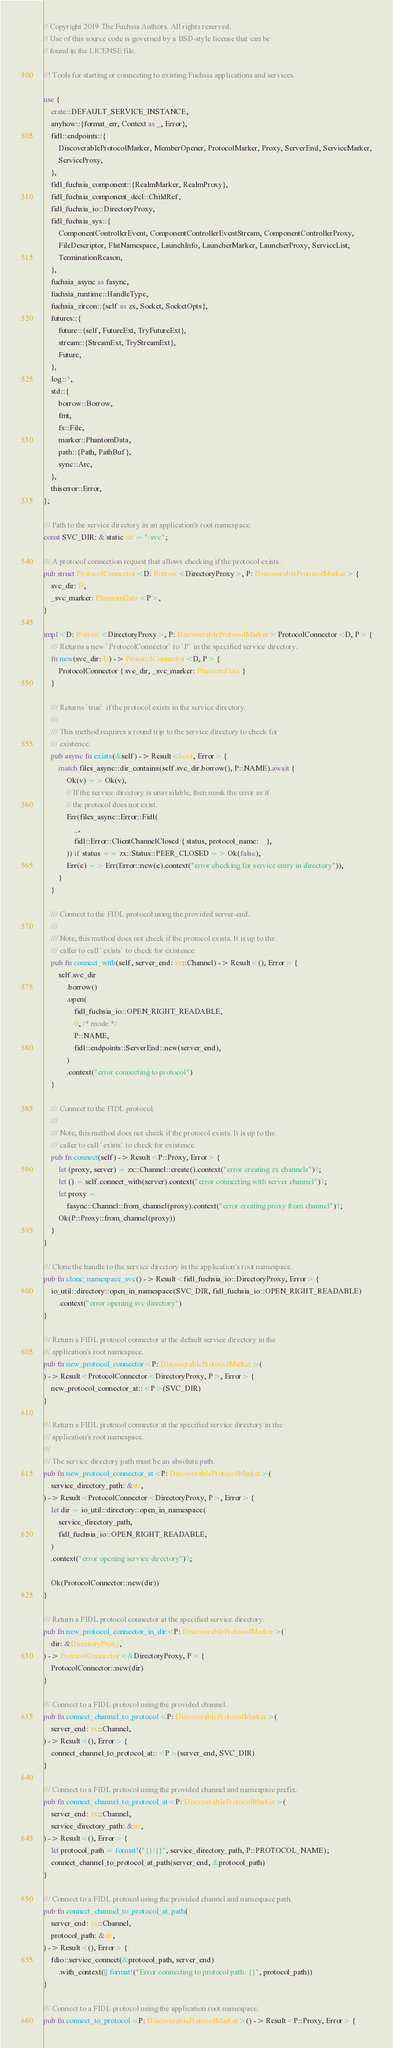<code> <loc_0><loc_0><loc_500><loc_500><_Rust_>// Copyright 2019 The Fuchsia Authors. All rights reserved.
// Use of this source code is governed by a BSD-style license that can be
// found in the LICENSE file.

//! Tools for starting or connecting to existing Fuchsia applications and services.

use {
    crate::DEFAULT_SERVICE_INSTANCE,
    anyhow::{format_err, Context as _, Error},
    fidl::endpoints::{
        DiscoverableProtocolMarker, MemberOpener, ProtocolMarker, Proxy, ServerEnd, ServiceMarker,
        ServiceProxy,
    },
    fidl_fuchsia_component::{RealmMarker, RealmProxy},
    fidl_fuchsia_component_decl::ChildRef,
    fidl_fuchsia_io::DirectoryProxy,
    fidl_fuchsia_sys::{
        ComponentControllerEvent, ComponentControllerEventStream, ComponentControllerProxy,
        FileDescriptor, FlatNamespace, LaunchInfo, LauncherMarker, LauncherProxy, ServiceList,
        TerminationReason,
    },
    fuchsia_async as fasync,
    fuchsia_runtime::HandleType,
    fuchsia_zircon::{self as zx, Socket, SocketOpts},
    futures::{
        future::{self, FutureExt, TryFutureExt},
        stream::{StreamExt, TryStreamExt},
        Future,
    },
    log::*,
    std::{
        borrow::Borrow,
        fmt,
        fs::File,
        marker::PhantomData,
        path::{Path, PathBuf},
        sync::Arc,
    },
    thiserror::Error,
};

/// Path to the service directory in an application's root namespace.
const SVC_DIR: &'static str = "/svc";

/// A protocol connection request that allows checking if the protocol exists.
pub struct ProtocolConnector<D: Borrow<DirectoryProxy>, P: DiscoverableProtocolMarker> {
    svc_dir: D,
    _svc_marker: PhantomData<P>,
}

impl<D: Borrow<DirectoryProxy>, P: DiscoverableProtocolMarker> ProtocolConnector<D, P> {
    /// Returns a new `ProtocolConnector` to `P` in the specified service directory.
    fn new(svc_dir: D) -> ProtocolConnector<D, P> {
        ProtocolConnector { svc_dir, _svc_marker: PhantomData }
    }

    /// Returns `true` if the protocol exists in the service directory.
    ///
    /// This method requires a round trip to the service directory to check for
    /// existence.
    pub async fn exists(&self) -> Result<bool, Error> {
        match files_async::dir_contains(self.svc_dir.borrow(), P::NAME).await {
            Ok(v) => Ok(v),
            // If the service directory is unavailable, then mask the error as if
            // the protocol does not exist.
            Err(files_async::Error::Fidl(
                _,
                fidl::Error::ClientChannelClosed { status, protocol_name: _ },
            )) if status == zx::Status::PEER_CLOSED => Ok(false),
            Err(e) => Err(Error::new(e).context("error checking for service entry in directory")),
        }
    }

    /// Connect to the FIDL protocol using the provided server-end.
    ///
    /// Note, this method does not check if the protocol exists. It is up to the
    /// caller to call `exists` to check for existence.
    pub fn connect_with(self, server_end: zx::Channel) -> Result<(), Error> {
        self.svc_dir
            .borrow()
            .open(
                fidl_fuchsia_io::OPEN_RIGHT_READABLE,
                0, /* mode */
                P::NAME,
                fidl::endpoints::ServerEnd::new(server_end),
            )
            .context("error connecting to protocol")
    }

    /// Connect to the FIDL protocol.
    ///
    /// Note, this method does not check if the protocol exists. It is up to the
    /// caller to call `exists` to check for existence.
    pub fn connect(self) -> Result<P::Proxy, Error> {
        let (proxy, server) = zx::Channel::create().context("error creating zx channels")?;
        let () = self.connect_with(server).context("error connecting with server channel")?;
        let proxy =
            fasync::Channel::from_channel(proxy).context("error creating proxy from channel")?;
        Ok(P::Proxy::from_channel(proxy))
    }
}

/// Clone the handle to the service directory in the application's root namespace.
pub fn clone_namespace_svc() -> Result<fidl_fuchsia_io::DirectoryProxy, Error> {
    io_util::directory::open_in_namespace(SVC_DIR, fidl_fuchsia_io::OPEN_RIGHT_READABLE)
        .context("error opening svc directory")
}

/// Return a FIDL protocol connector at the default service directory in the
/// application's root namespace.
pub fn new_protocol_connector<P: DiscoverableProtocolMarker>(
) -> Result<ProtocolConnector<DirectoryProxy, P>, Error> {
    new_protocol_connector_at::<P>(SVC_DIR)
}

/// Return a FIDL protocol connector at the specified service directory in the
/// application's root namespace.
///
/// The service directory path must be an absolute path.
pub fn new_protocol_connector_at<P: DiscoverableProtocolMarker>(
    service_directory_path: &str,
) -> Result<ProtocolConnector<DirectoryProxy, P>, Error> {
    let dir = io_util::directory::open_in_namespace(
        service_directory_path,
        fidl_fuchsia_io::OPEN_RIGHT_READABLE,
    )
    .context("error opening service directory")?;

    Ok(ProtocolConnector::new(dir))
}

/// Return a FIDL protocol connector at the specified service directory.
pub fn new_protocol_connector_in_dir<P: DiscoverableProtocolMarker>(
    dir: &DirectoryProxy,
) -> ProtocolConnector<&DirectoryProxy, P> {
    ProtocolConnector::new(dir)
}

/// Connect to a FIDL protocol using the provided channel.
pub fn connect_channel_to_protocol<P: DiscoverableProtocolMarker>(
    server_end: zx::Channel,
) -> Result<(), Error> {
    connect_channel_to_protocol_at::<P>(server_end, SVC_DIR)
}

/// Connect to a FIDL protocol using the provided channel and namespace prefix.
pub fn connect_channel_to_protocol_at<P: DiscoverableProtocolMarker>(
    server_end: zx::Channel,
    service_directory_path: &str,
) -> Result<(), Error> {
    let protocol_path = format!("{}/{}", service_directory_path, P::PROTOCOL_NAME);
    connect_channel_to_protocol_at_path(server_end, &protocol_path)
}

/// Connect to a FIDL protocol using the provided channel and namespace path.
pub fn connect_channel_to_protocol_at_path(
    server_end: zx::Channel,
    protocol_path: &str,
) -> Result<(), Error> {
    fdio::service_connect(&protocol_path, server_end)
        .with_context(|| format!("Error connecting to protocol path: {}", protocol_path))
}

/// Connect to a FIDL protocol using the application root namespace.
pub fn connect_to_protocol<P: DiscoverableProtocolMarker>() -> Result<P::Proxy, Error> {</code> 